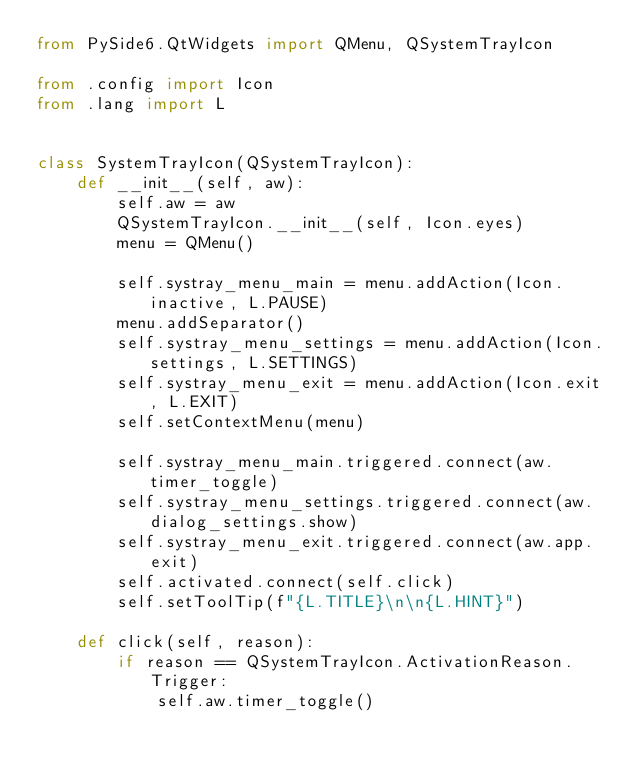Convert code to text. <code><loc_0><loc_0><loc_500><loc_500><_Python_>from PySide6.QtWidgets import QMenu, QSystemTrayIcon

from .config import Icon
from .lang import L


class SystemTrayIcon(QSystemTrayIcon):
    def __init__(self, aw):
        self.aw = aw
        QSystemTrayIcon.__init__(self, Icon.eyes)
        menu = QMenu()

        self.systray_menu_main = menu.addAction(Icon.inactive, L.PAUSE)
        menu.addSeparator()
        self.systray_menu_settings = menu.addAction(Icon.settings, L.SETTINGS)
        self.systray_menu_exit = menu.addAction(Icon.exit, L.EXIT)
        self.setContextMenu(menu)

        self.systray_menu_main.triggered.connect(aw.timer_toggle)
        self.systray_menu_settings.triggered.connect(aw.dialog_settings.show)
        self.systray_menu_exit.triggered.connect(aw.app.exit)
        self.activated.connect(self.click)
        self.setToolTip(f"{L.TITLE}\n\n{L.HINT}")

    def click(self, reason):
        if reason == QSystemTrayIcon.ActivationReason.Trigger:
            self.aw.timer_toggle()
</code> 